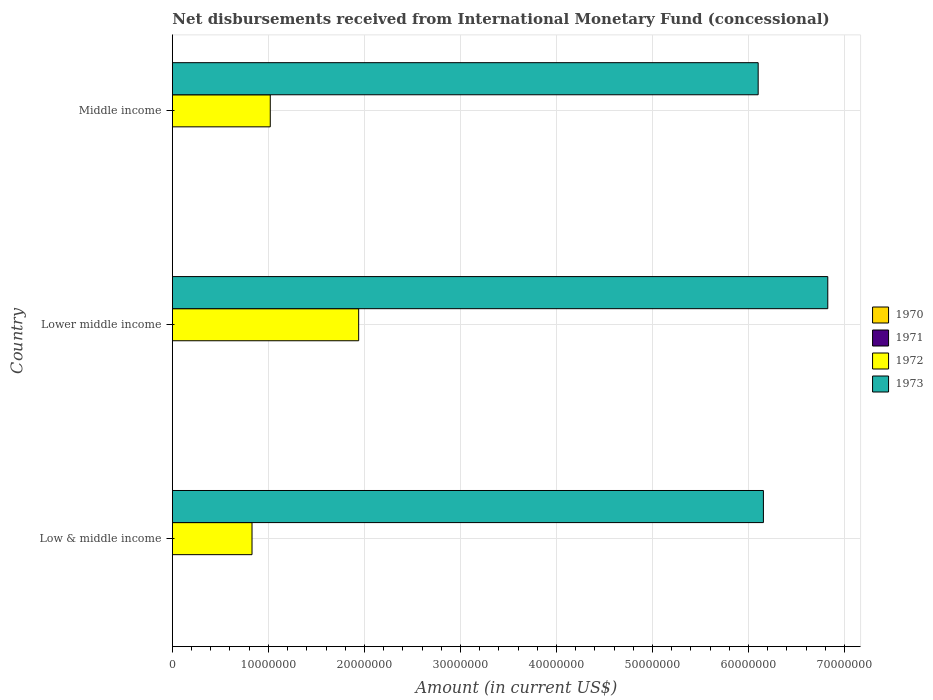How many different coloured bars are there?
Your response must be concise. 2. Are the number of bars on each tick of the Y-axis equal?
Your answer should be very brief. Yes. How many bars are there on the 1st tick from the bottom?
Give a very brief answer. 2. What is the label of the 1st group of bars from the top?
Your answer should be very brief. Middle income. In how many cases, is the number of bars for a given country not equal to the number of legend labels?
Your answer should be very brief. 3. What is the amount of disbursements received from International Monetary Fund in 1973 in Middle income?
Keep it short and to the point. 6.10e+07. Across all countries, what is the maximum amount of disbursements received from International Monetary Fund in 1972?
Ensure brevity in your answer.  1.94e+07. Across all countries, what is the minimum amount of disbursements received from International Monetary Fund in 1971?
Make the answer very short. 0. In which country was the amount of disbursements received from International Monetary Fund in 1972 maximum?
Ensure brevity in your answer.  Lower middle income. What is the total amount of disbursements received from International Monetary Fund in 1973 in the graph?
Offer a terse response. 1.91e+08. What is the difference between the amount of disbursements received from International Monetary Fund in 1973 in Low & middle income and that in Middle income?
Keep it short and to the point. 5.46e+05. What is the difference between the amount of disbursements received from International Monetary Fund in 1973 in Middle income and the amount of disbursements received from International Monetary Fund in 1971 in Low & middle income?
Offer a very short reply. 6.10e+07. What is the average amount of disbursements received from International Monetary Fund in 1972 per country?
Make the answer very short. 1.26e+07. What is the difference between the amount of disbursements received from International Monetary Fund in 1972 and amount of disbursements received from International Monetary Fund in 1973 in Low & middle income?
Your answer should be compact. -5.33e+07. In how many countries, is the amount of disbursements received from International Monetary Fund in 1970 greater than 12000000 US$?
Give a very brief answer. 0. What is the ratio of the amount of disbursements received from International Monetary Fund in 1972 in Lower middle income to that in Middle income?
Your answer should be very brief. 1.9. What is the difference between the highest and the second highest amount of disbursements received from International Monetary Fund in 1972?
Your answer should be compact. 9.21e+06. What is the difference between the highest and the lowest amount of disbursements received from International Monetary Fund in 1972?
Keep it short and to the point. 1.11e+07. Is the sum of the amount of disbursements received from International Monetary Fund in 1973 in Low & middle income and Middle income greater than the maximum amount of disbursements received from International Monetary Fund in 1972 across all countries?
Offer a terse response. Yes. Are all the bars in the graph horizontal?
Your answer should be very brief. Yes. How many countries are there in the graph?
Ensure brevity in your answer.  3. Are the values on the major ticks of X-axis written in scientific E-notation?
Make the answer very short. No. Does the graph contain any zero values?
Give a very brief answer. Yes. Does the graph contain grids?
Your answer should be compact. Yes. What is the title of the graph?
Offer a terse response. Net disbursements received from International Monetary Fund (concessional). Does "2006" appear as one of the legend labels in the graph?
Ensure brevity in your answer.  No. What is the Amount (in current US$) of 1970 in Low & middle income?
Make the answer very short. 0. What is the Amount (in current US$) of 1972 in Low & middle income?
Your answer should be very brief. 8.30e+06. What is the Amount (in current US$) of 1973 in Low & middle income?
Offer a very short reply. 6.16e+07. What is the Amount (in current US$) in 1970 in Lower middle income?
Provide a succinct answer. 0. What is the Amount (in current US$) of 1971 in Lower middle income?
Your response must be concise. 0. What is the Amount (in current US$) in 1972 in Lower middle income?
Offer a terse response. 1.94e+07. What is the Amount (in current US$) in 1973 in Lower middle income?
Your answer should be very brief. 6.83e+07. What is the Amount (in current US$) of 1970 in Middle income?
Your response must be concise. 0. What is the Amount (in current US$) in 1971 in Middle income?
Give a very brief answer. 0. What is the Amount (in current US$) of 1972 in Middle income?
Offer a terse response. 1.02e+07. What is the Amount (in current US$) in 1973 in Middle income?
Your answer should be compact. 6.10e+07. Across all countries, what is the maximum Amount (in current US$) of 1972?
Your answer should be very brief. 1.94e+07. Across all countries, what is the maximum Amount (in current US$) of 1973?
Your answer should be very brief. 6.83e+07. Across all countries, what is the minimum Amount (in current US$) of 1972?
Your answer should be very brief. 8.30e+06. Across all countries, what is the minimum Amount (in current US$) in 1973?
Your answer should be very brief. 6.10e+07. What is the total Amount (in current US$) of 1970 in the graph?
Ensure brevity in your answer.  0. What is the total Amount (in current US$) in 1971 in the graph?
Your answer should be compact. 0. What is the total Amount (in current US$) of 1972 in the graph?
Provide a short and direct response. 3.79e+07. What is the total Amount (in current US$) of 1973 in the graph?
Give a very brief answer. 1.91e+08. What is the difference between the Amount (in current US$) in 1972 in Low & middle income and that in Lower middle income?
Give a very brief answer. -1.11e+07. What is the difference between the Amount (in current US$) of 1973 in Low & middle income and that in Lower middle income?
Offer a terse response. -6.70e+06. What is the difference between the Amount (in current US$) of 1972 in Low & middle income and that in Middle income?
Make the answer very short. -1.90e+06. What is the difference between the Amount (in current US$) of 1973 in Low & middle income and that in Middle income?
Provide a short and direct response. 5.46e+05. What is the difference between the Amount (in current US$) of 1972 in Lower middle income and that in Middle income?
Offer a very short reply. 9.21e+06. What is the difference between the Amount (in current US$) in 1973 in Lower middle income and that in Middle income?
Offer a terse response. 7.25e+06. What is the difference between the Amount (in current US$) in 1972 in Low & middle income and the Amount (in current US$) in 1973 in Lower middle income?
Ensure brevity in your answer.  -6.00e+07. What is the difference between the Amount (in current US$) in 1972 in Low & middle income and the Amount (in current US$) in 1973 in Middle income?
Your answer should be very brief. -5.27e+07. What is the difference between the Amount (in current US$) of 1972 in Lower middle income and the Amount (in current US$) of 1973 in Middle income?
Offer a terse response. -4.16e+07. What is the average Amount (in current US$) of 1972 per country?
Provide a succinct answer. 1.26e+07. What is the average Amount (in current US$) in 1973 per country?
Provide a succinct answer. 6.36e+07. What is the difference between the Amount (in current US$) in 1972 and Amount (in current US$) in 1973 in Low & middle income?
Your response must be concise. -5.33e+07. What is the difference between the Amount (in current US$) of 1972 and Amount (in current US$) of 1973 in Lower middle income?
Your response must be concise. -4.89e+07. What is the difference between the Amount (in current US$) in 1972 and Amount (in current US$) in 1973 in Middle income?
Your answer should be compact. -5.08e+07. What is the ratio of the Amount (in current US$) of 1972 in Low & middle income to that in Lower middle income?
Your answer should be compact. 0.43. What is the ratio of the Amount (in current US$) of 1973 in Low & middle income to that in Lower middle income?
Your answer should be compact. 0.9. What is the ratio of the Amount (in current US$) in 1972 in Low & middle income to that in Middle income?
Provide a short and direct response. 0.81. What is the ratio of the Amount (in current US$) of 1973 in Low & middle income to that in Middle income?
Offer a terse response. 1.01. What is the ratio of the Amount (in current US$) in 1972 in Lower middle income to that in Middle income?
Your answer should be very brief. 1.9. What is the ratio of the Amount (in current US$) in 1973 in Lower middle income to that in Middle income?
Give a very brief answer. 1.12. What is the difference between the highest and the second highest Amount (in current US$) of 1972?
Your response must be concise. 9.21e+06. What is the difference between the highest and the second highest Amount (in current US$) of 1973?
Keep it short and to the point. 6.70e+06. What is the difference between the highest and the lowest Amount (in current US$) in 1972?
Make the answer very short. 1.11e+07. What is the difference between the highest and the lowest Amount (in current US$) in 1973?
Your answer should be very brief. 7.25e+06. 